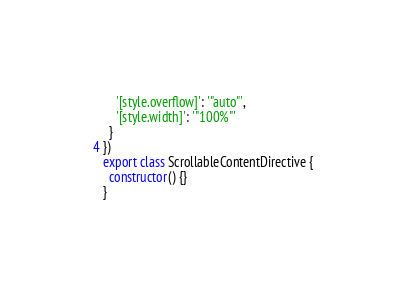<code> <loc_0><loc_0><loc_500><loc_500><_TypeScript_>    '[style.overflow]': '"auto"',
    '[style.width]': '"100%"'
  }
})
export class ScrollableContentDirective {
  constructor() {}
}
</code> 